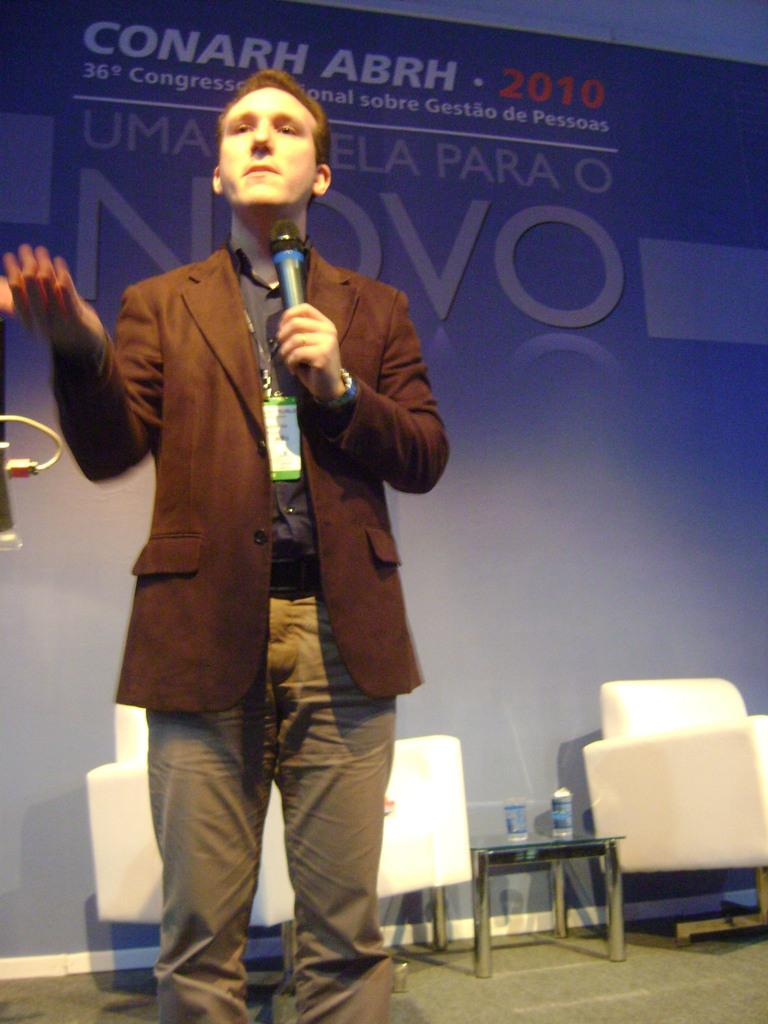What is the person in the image holding? The person is holding a mic in his hand. What type of clothing is the person wearing? The person is dressed in a blazer. What can be seen in the background of the image? There are white-colored sofas and a table in the background. How much income does the bird in the image earn? There is no bird present in the image, so it is not possible to determine its income. 